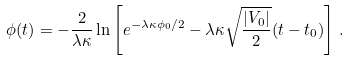Convert formula to latex. <formula><loc_0><loc_0><loc_500><loc_500>\phi ( t ) = - \frac { 2 } { \lambda \kappa } \ln \left [ e ^ { - \lambda \kappa \phi _ { 0 } / 2 } - \lambda \kappa \sqrt { \frac { | V _ { 0 } | } { 2 } } ( t - t _ { 0 } ) \right ] \, .</formula> 